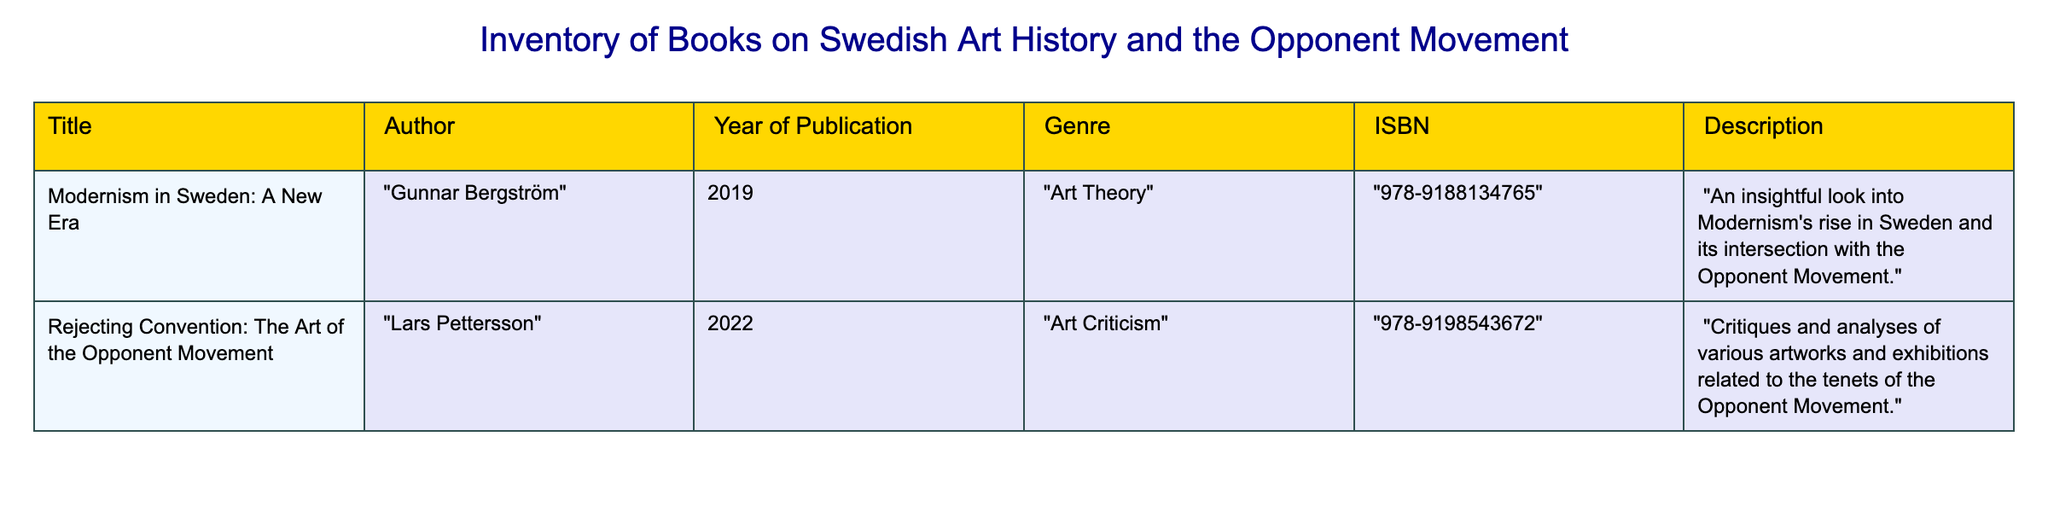What is the title of the book written by Lars Pettersson? The table shows the title and author for each row. To find the title by Lars Pettersson, I look under the Author column and find his name; the corresponding title is "Rejecting Convention: The Art of the Opponent Movement."
Answer: "Rejecting Convention: The Art of the Opponent Movement" How many books are listed in the inventory? Counting the rows in the table, there are two distinct titles listed in the inventory: one by Gunnar Bergström and another by Lars Pettersson.
Answer: 2 Is there a book published in 2019? I inspect the Year of Publication column and find that there is an entry for 2019, which corresponds to the book "Modernism in Sweden: A New Era" by Gunnar Bergström. This confirms the existence of a publication from that year.
Answer: Yes What genre does the book written by Gunnar Bergström belong to? To find the genre of Gunnar Bergström's book, I first identify the title "Modernism in Sweden: A New Era" and then look across to the Genre column, which indicates it is categorized under "Art Theory."
Answer: Art Theory Which book has the ISBN number 978-9198543672? I refer to the ISBN column and locate the number 978-9198543672. Checking the corresponding title to this ISBN, I find it belongs to "Rejecting Convention: The Art of the Opponent Movement" by Lars Pettersson.
Answer: "Rejecting Convention: The Art of the Opponent Movement" What is the average year of publication for the books listed? The two books were published in 2019 and 2022 respectively. To find the average, I sum the years (2019 + 2022 = 4041) and then divide by the number of books (4041/2 = 2020.5). The average year of publication is thus approximately 2021 when rounded.
Answer: 2021 Does the table contain more books published after 2020 than before? I evaluate the years of publication: one book was published in 2019 (before 2020) and the other in 2022 (after 2020). Since there is one book published before 2020 and one after, the answer is clearly established.
Answer: No What is the total number of different genres listed in the inventory? I check the Genre column for diversity in genre types. There are two genres present: "Art Theory" from Gunnar Bergström's book and "Art Criticism" from Lars Pettersson's book. Since these are distinct, I count them to determine the total.
Answer: 2 